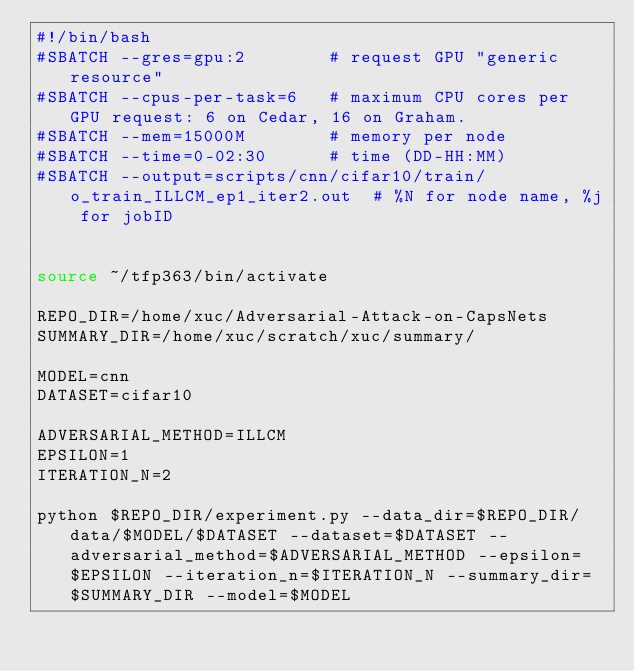<code> <loc_0><loc_0><loc_500><loc_500><_Bash_>#!/bin/bash
#SBATCH --gres=gpu:2        # request GPU "generic resource"
#SBATCH --cpus-per-task=6   # maximum CPU cores per GPU request: 6 on Cedar, 16 on Graham.
#SBATCH --mem=15000M        # memory per node
#SBATCH --time=0-02:30      # time (DD-HH:MM)
#SBATCH --output=scripts/cnn/cifar10/train/o_train_ILLCM_ep1_iter2.out  # %N for node name, %j for jobID


source ~/tfp363/bin/activate

REPO_DIR=/home/xuc/Adversarial-Attack-on-CapsNets
SUMMARY_DIR=/home/xuc/scratch/xuc/summary/

MODEL=cnn
DATASET=cifar10

ADVERSARIAL_METHOD=ILLCM 
EPSILON=1
ITERATION_N=2

python $REPO_DIR/experiment.py --data_dir=$REPO_DIR/data/$MODEL/$DATASET --dataset=$DATASET --adversarial_method=$ADVERSARIAL_METHOD --epsilon=$EPSILON --iteration_n=$ITERATION_N --summary_dir=$SUMMARY_DIR --model=$MODEL
</code> 